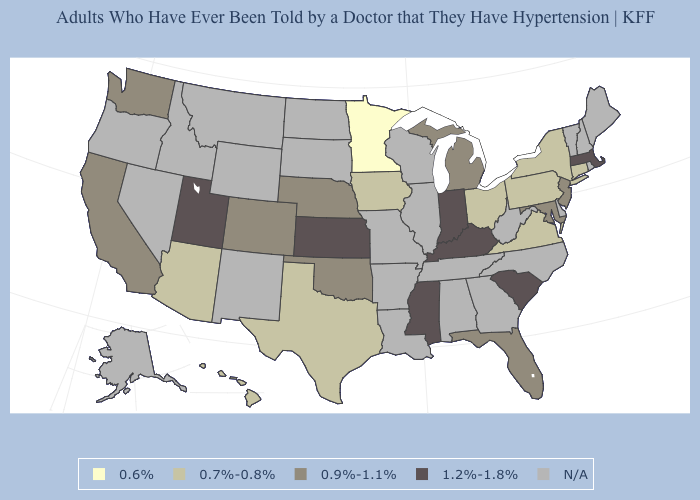What is the lowest value in the West?
Write a very short answer. 0.7%-0.8%. What is the value of California?
Give a very brief answer. 0.9%-1.1%. What is the highest value in the USA?
Be succinct. 1.2%-1.8%. What is the value of Florida?
Keep it brief. 0.9%-1.1%. Name the states that have a value in the range 0.6%?
Answer briefly. Minnesota. Does the first symbol in the legend represent the smallest category?
Short answer required. Yes. Does the map have missing data?
Answer briefly. Yes. Which states have the lowest value in the West?
Write a very short answer. Arizona, Hawaii. Which states have the lowest value in the USA?
Concise answer only. Minnesota. Does Texas have the highest value in the USA?
Be succinct. No. Among the states that border California , which have the lowest value?
Be succinct. Arizona. Does Hawaii have the lowest value in the USA?
Answer briefly. No. Which states have the lowest value in the USA?
Answer briefly. Minnesota. 